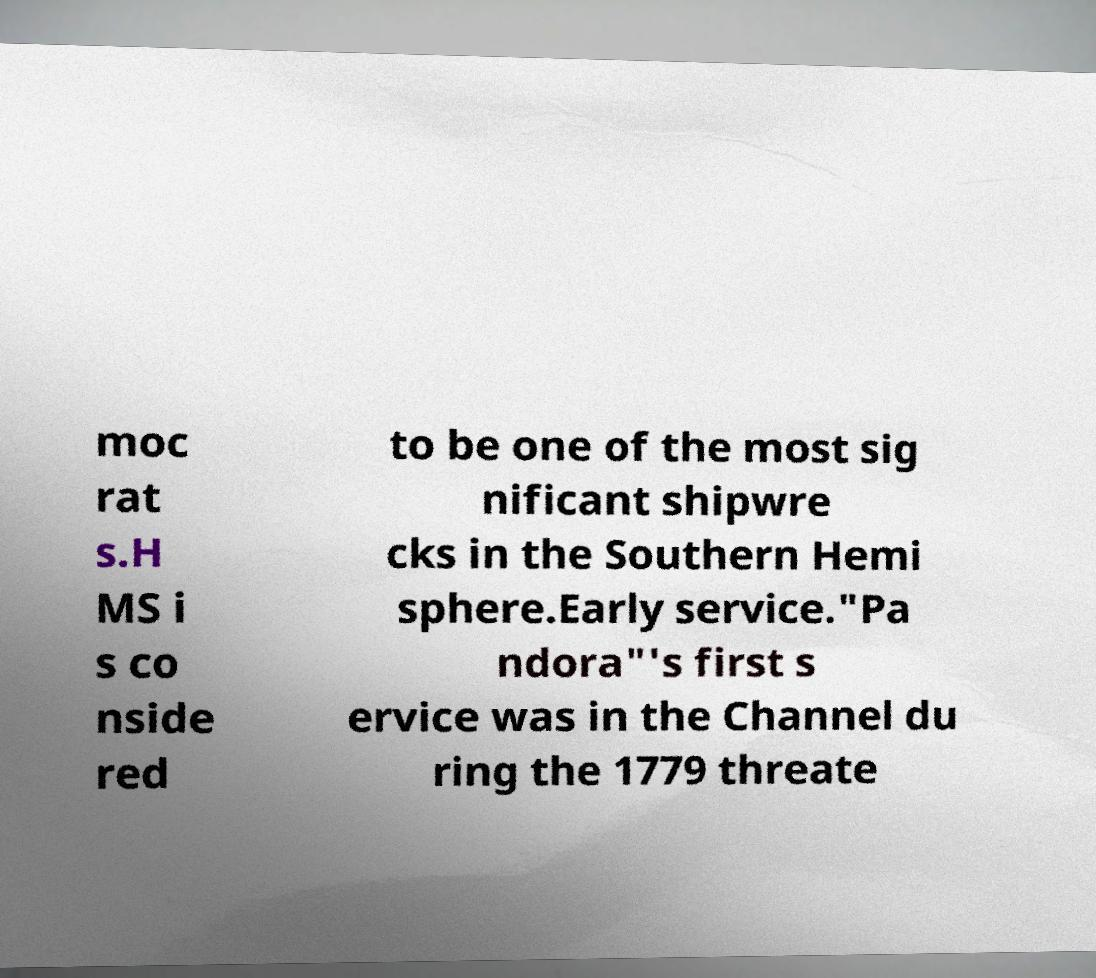I need the written content from this picture converted into text. Can you do that? moc rat s.H MS i s co nside red to be one of the most sig nificant shipwre cks in the Southern Hemi sphere.Early service."Pa ndora"'s first s ervice was in the Channel du ring the 1779 threate 